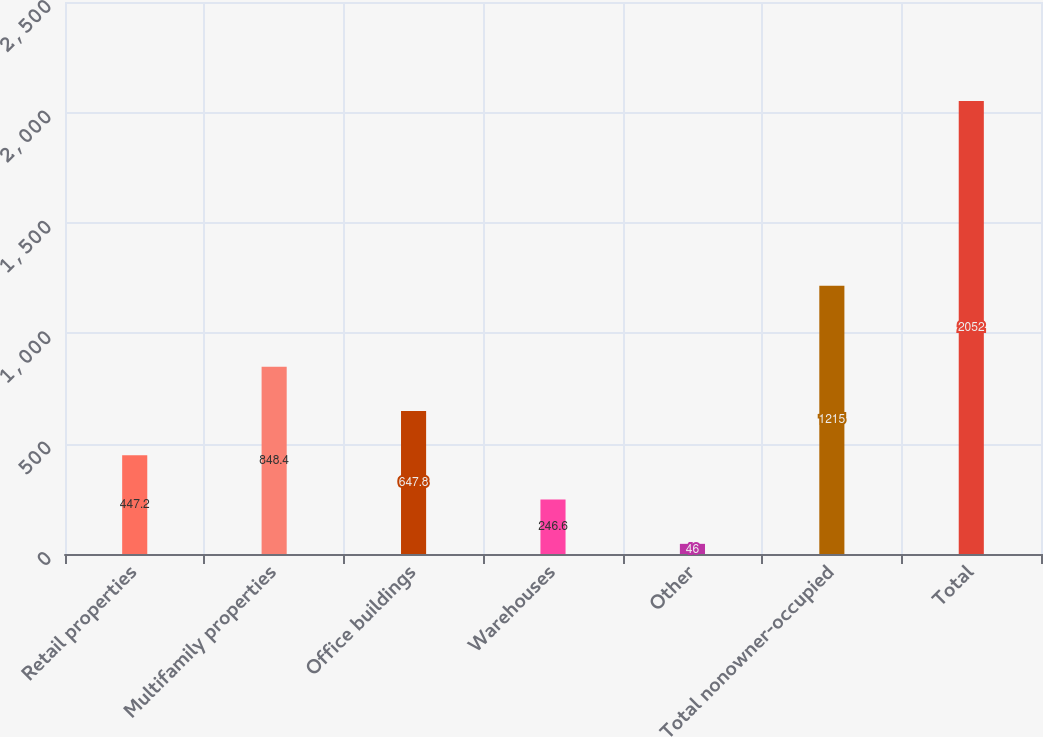Convert chart to OTSL. <chart><loc_0><loc_0><loc_500><loc_500><bar_chart><fcel>Retail properties<fcel>Multifamily properties<fcel>Office buildings<fcel>Warehouses<fcel>Other<fcel>Total nonowner-occupied<fcel>Total<nl><fcel>447.2<fcel>848.4<fcel>647.8<fcel>246.6<fcel>46<fcel>1215<fcel>2052<nl></chart> 